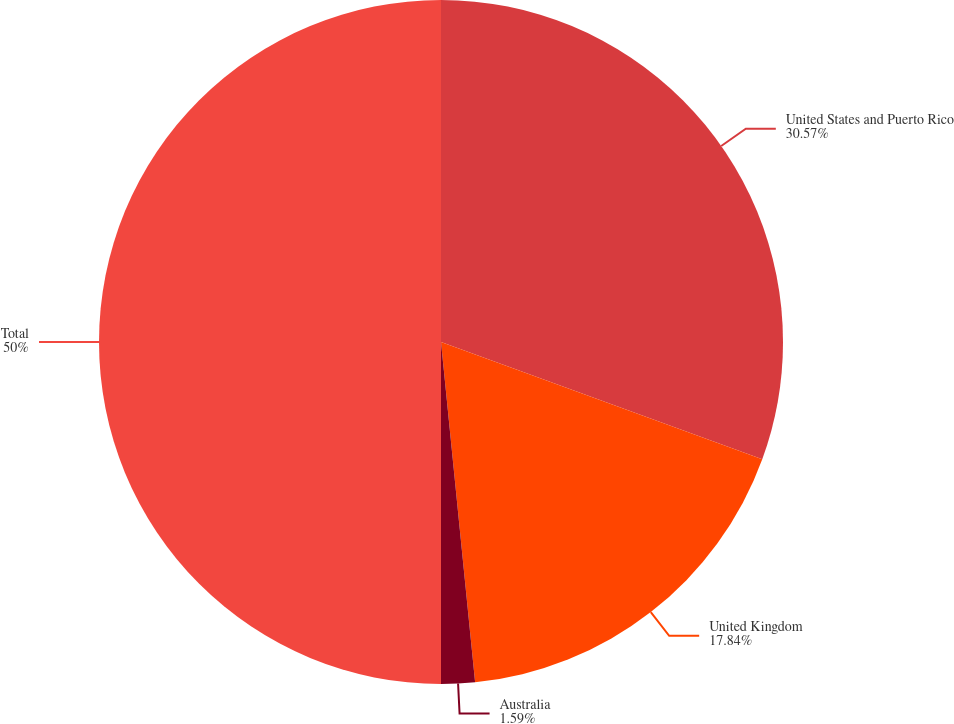Convert chart. <chart><loc_0><loc_0><loc_500><loc_500><pie_chart><fcel>United States and Puerto Rico<fcel>United Kingdom<fcel>Australia<fcel>Total<nl><fcel>30.57%<fcel>17.84%<fcel>1.59%<fcel>50.0%<nl></chart> 